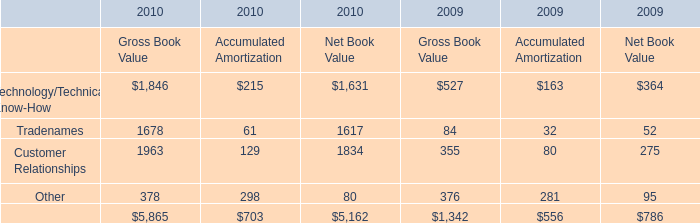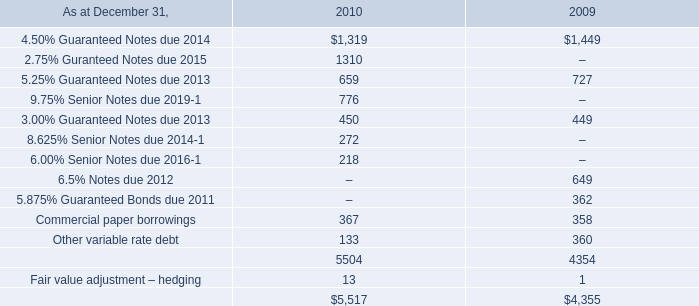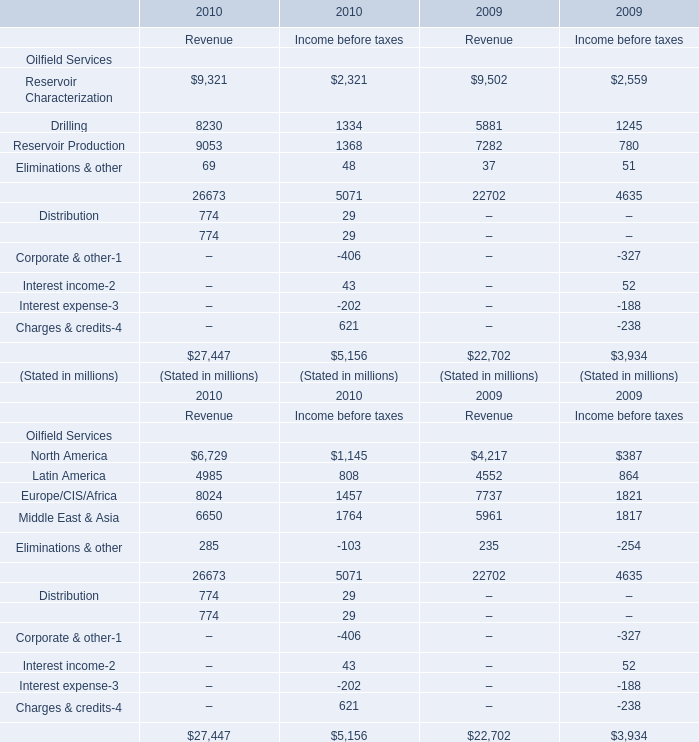what was the growth rate of the schlumberger interest expense from 2010 to 2011 
Computations: (91 / (298 - 91))
Answer: 0.43961. 